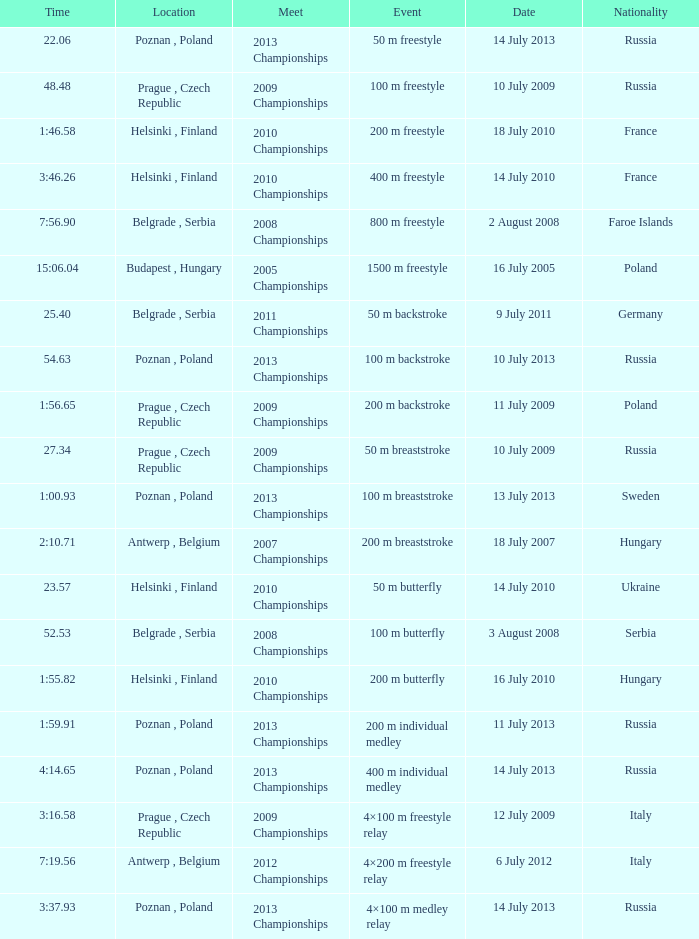Where were the 2008 championships with a time of 7:56.90 held? Belgrade , Serbia. 